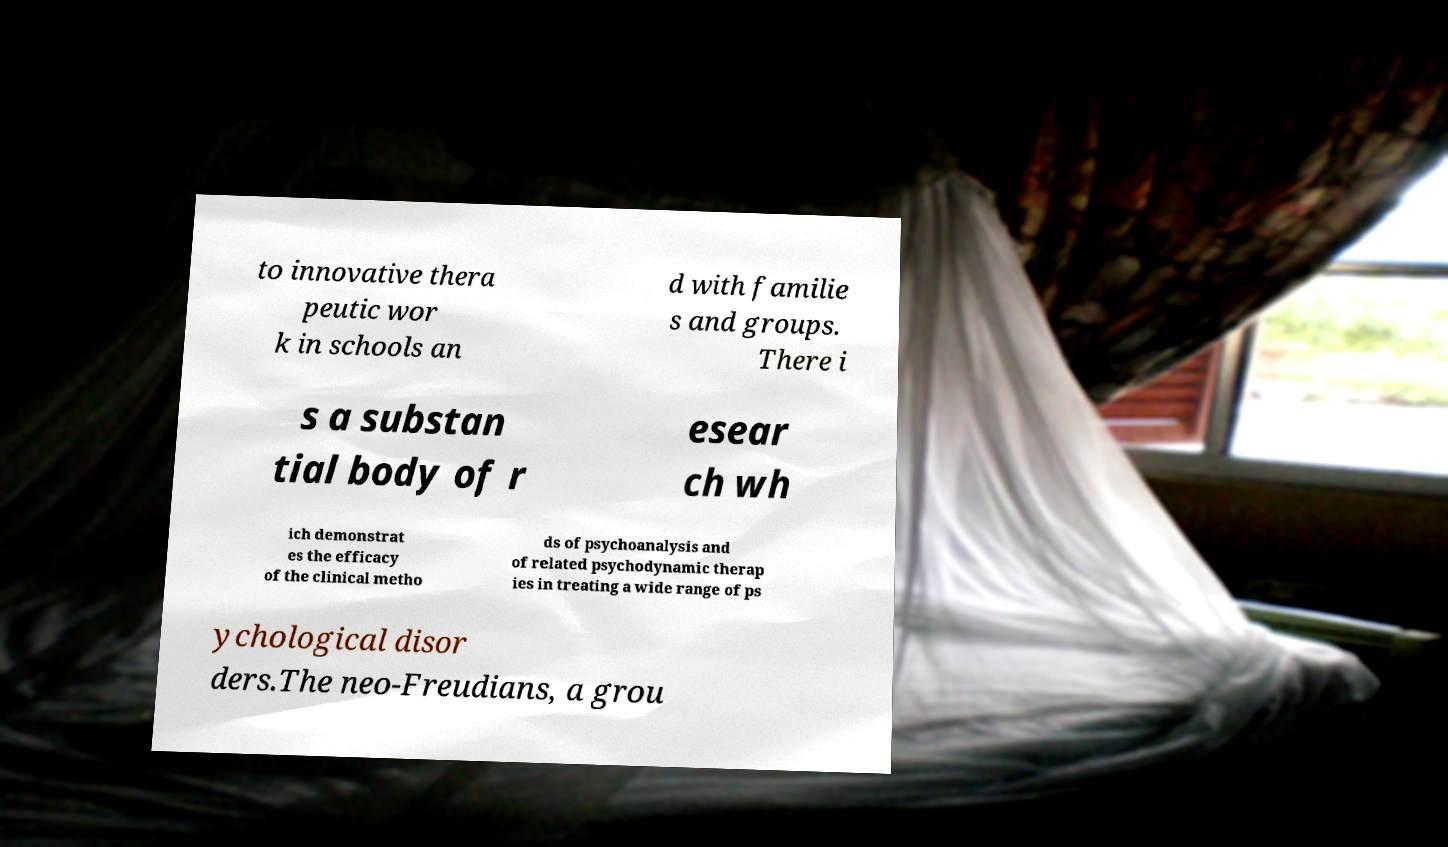Can you accurately transcribe the text from the provided image for me? to innovative thera peutic wor k in schools an d with familie s and groups. There i s a substan tial body of r esear ch wh ich demonstrat es the efficacy of the clinical metho ds of psychoanalysis and of related psychodynamic therap ies in treating a wide range of ps ychological disor ders.The neo-Freudians, a grou 